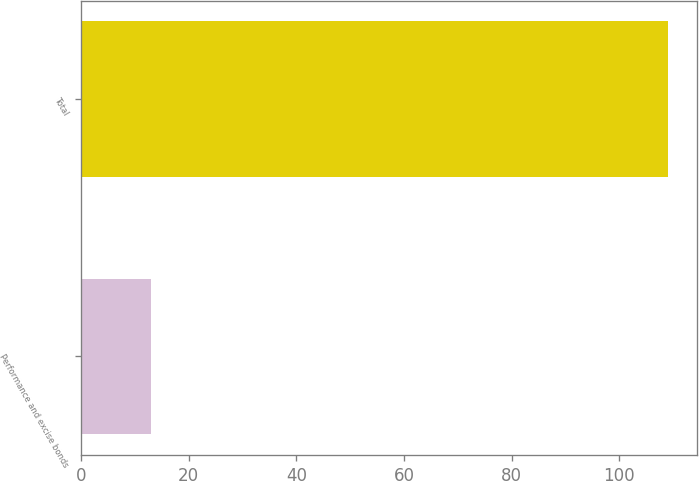<chart> <loc_0><loc_0><loc_500><loc_500><bar_chart><fcel>Performance and excise bonds<fcel>Total<nl><fcel>13<fcel>109<nl></chart> 